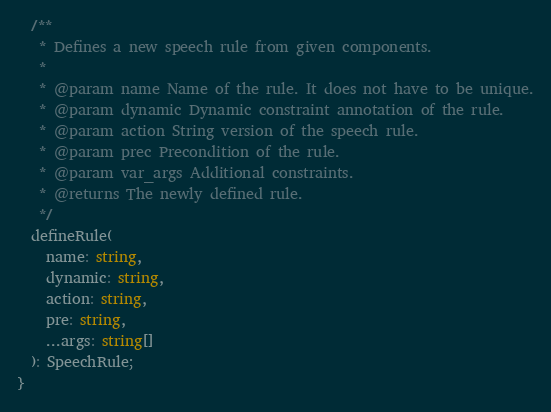<code> <loc_0><loc_0><loc_500><loc_500><_TypeScript_>  /**
   * Defines a new speech rule from given components.
   *
   * @param name Name of the rule. It does not have to be unique.
   * @param dynamic Dynamic constraint annotation of the rule.
   * @param action String version of the speech rule.
   * @param prec Precondition of the rule.
   * @param var_args Additional constraints.
   * @returns The newly defined rule.
   */
  defineRule(
    name: string,
    dynamic: string,
    action: string,
    pre: string,
    ...args: string[]
  ): SpeechRule;
}
</code> 